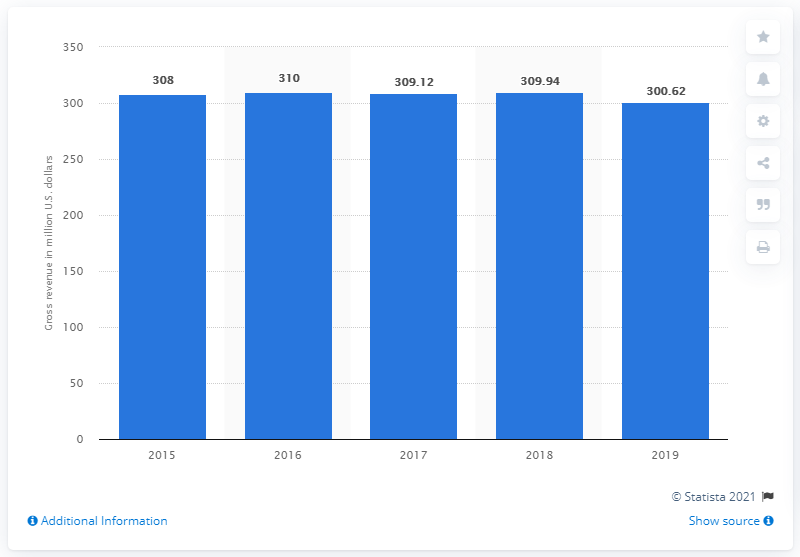Draw attention to some important aspects in this diagram. In 2019, Finnegan, Henderson, Farabow, Garrett & Dunner's gross revenue was 300.62 million dollars. 